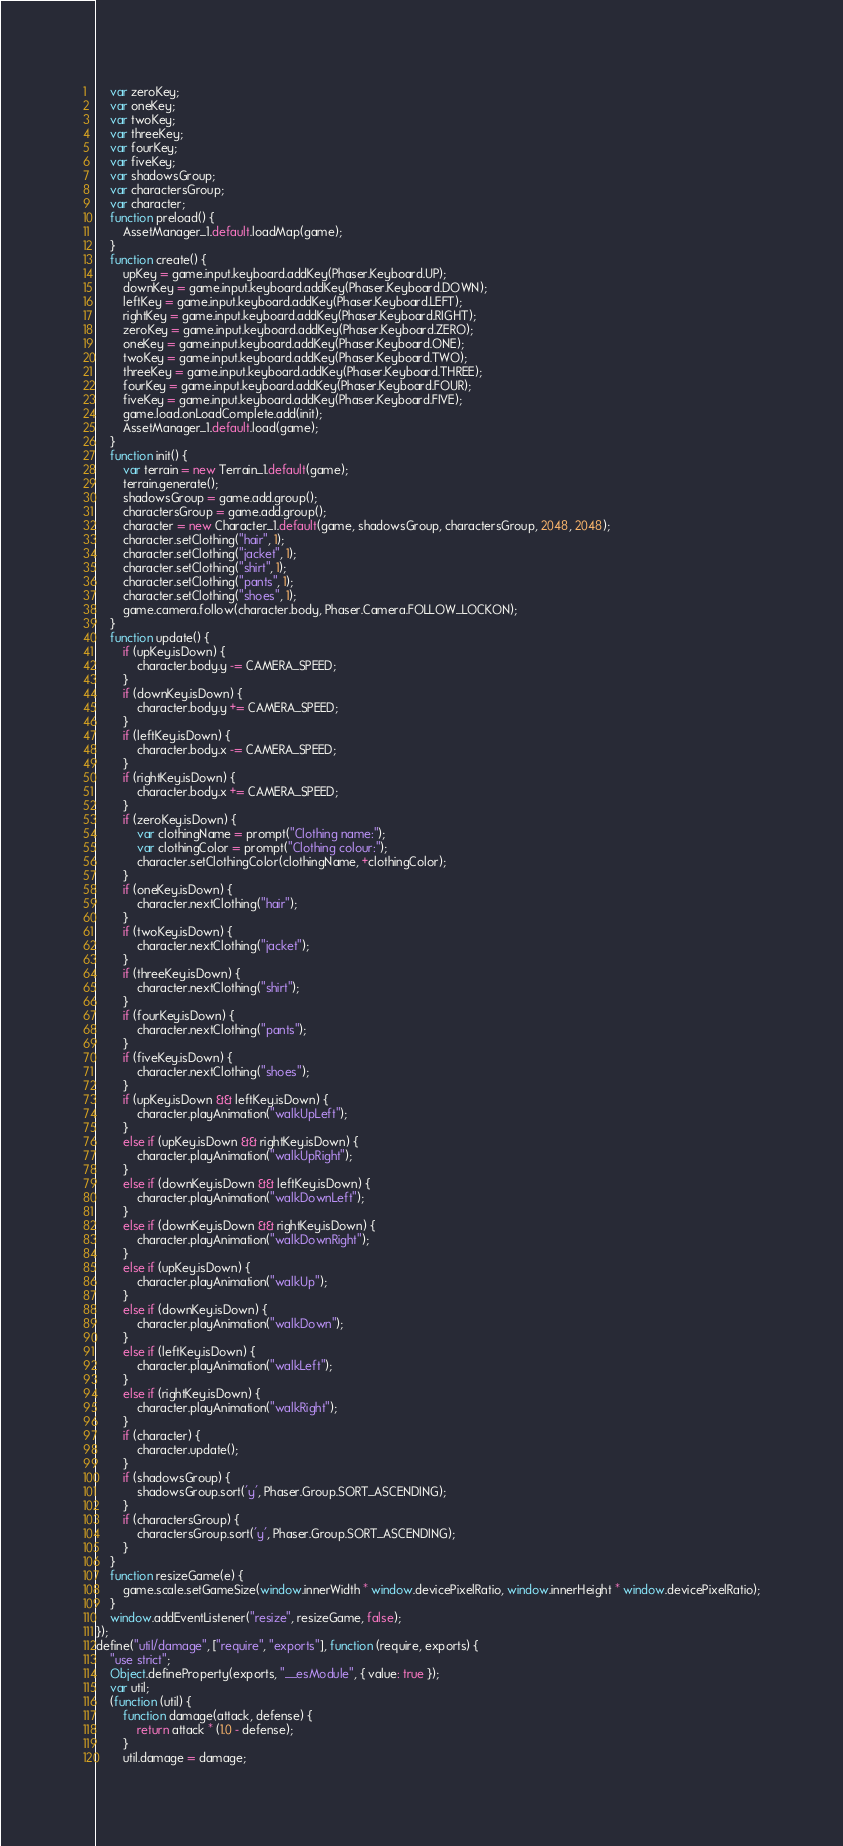<code> <loc_0><loc_0><loc_500><loc_500><_JavaScript_>    var zeroKey;
    var oneKey;
    var twoKey;
    var threeKey;
    var fourKey;
    var fiveKey;
    var shadowsGroup;
    var charactersGroup;
    var character;
    function preload() {
        AssetManager_1.default.loadMap(game);
    }
    function create() {
        upKey = game.input.keyboard.addKey(Phaser.Keyboard.UP);
        downKey = game.input.keyboard.addKey(Phaser.Keyboard.DOWN);
        leftKey = game.input.keyboard.addKey(Phaser.Keyboard.LEFT);
        rightKey = game.input.keyboard.addKey(Phaser.Keyboard.RIGHT);
        zeroKey = game.input.keyboard.addKey(Phaser.Keyboard.ZERO);
        oneKey = game.input.keyboard.addKey(Phaser.Keyboard.ONE);
        twoKey = game.input.keyboard.addKey(Phaser.Keyboard.TWO);
        threeKey = game.input.keyboard.addKey(Phaser.Keyboard.THREE);
        fourKey = game.input.keyboard.addKey(Phaser.Keyboard.FOUR);
        fiveKey = game.input.keyboard.addKey(Phaser.Keyboard.FIVE);
        game.load.onLoadComplete.add(init);
        AssetManager_1.default.load(game);
    }
    function init() {
        var terrain = new Terrain_1.default(game);
        terrain.generate();
        shadowsGroup = game.add.group();
        charactersGroup = game.add.group();
        character = new Character_1.default(game, shadowsGroup, charactersGroup, 2048, 2048);
        character.setClothing("hair", 1);
        character.setClothing("jacket", 1);
        character.setClothing("shirt", 1);
        character.setClothing("pants", 1);
        character.setClothing("shoes", 1);
        game.camera.follow(character.body, Phaser.Camera.FOLLOW_LOCKON);
    }
    function update() {
        if (upKey.isDown) {
            character.body.y -= CAMERA_SPEED;
        }
        if (downKey.isDown) {
            character.body.y += CAMERA_SPEED;
        }
        if (leftKey.isDown) {
            character.body.x -= CAMERA_SPEED;
        }
        if (rightKey.isDown) {
            character.body.x += CAMERA_SPEED;
        }
        if (zeroKey.isDown) {
            var clothingName = prompt("Clothing name:");
            var clothingColor = prompt("Clothing colour:");
            character.setClothingColor(clothingName, +clothingColor);
        }
        if (oneKey.isDown) {
            character.nextClothing("hair");
        }
        if (twoKey.isDown) {
            character.nextClothing("jacket");
        }
        if (threeKey.isDown) {
            character.nextClothing("shirt");
        }
        if (fourKey.isDown) {
            character.nextClothing("pants");
        }
        if (fiveKey.isDown) {
            character.nextClothing("shoes");
        }
        if (upKey.isDown && leftKey.isDown) {
            character.playAnimation("walkUpLeft");
        }
        else if (upKey.isDown && rightKey.isDown) {
            character.playAnimation("walkUpRight");
        }
        else if (downKey.isDown && leftKey.isDown) {
            character.playAnimation("walkDownLeft");
        }
        else if (downKey.isDown && rightKey.isDown) {
            character.playAnimation("walkDownRight");
        }
        else if (upKey.isDown) {
            character.playAnimation("walkUp");
        }
        else if (downKey.isDown) {
            character.playAnimation("walkDown");
        }
        else if (leftKey.isDown) {
            character.playAnimation("walkLeft");
        }
        else if (rightKey.isDown) {
            character.playAnimation("walkRight");
        }
        if (character) {
            character.update();
        }
        if (shadowsGroup) {
            shadowsGroup.sort('y', Phaser.Group.SORT_ASCENDING);
        }
        if (charactersGroup) {
            charactersGroup.sort('y', Phaser.Group.SORT_ASCENDING);
        }
    }
    function resizeGame(e) {
        game.scale.setGameSize(window.innerWidth * window.devicePixelRatio, window.innerHeight * window.devicePixelRatio);
    }
    window.addEventListener("resize", resizeGame, false);
});
define("util/damage", ["require", "exports"], function (require, exports) {
    "use strict";
    Object.defineProperty(exports, "__esModule", { value: true });
    var util;
    (function (util) {
        function damage(attack, defense) {
            return attack * (1.0 - defense);
        }
        util.damage = damage;</code> 